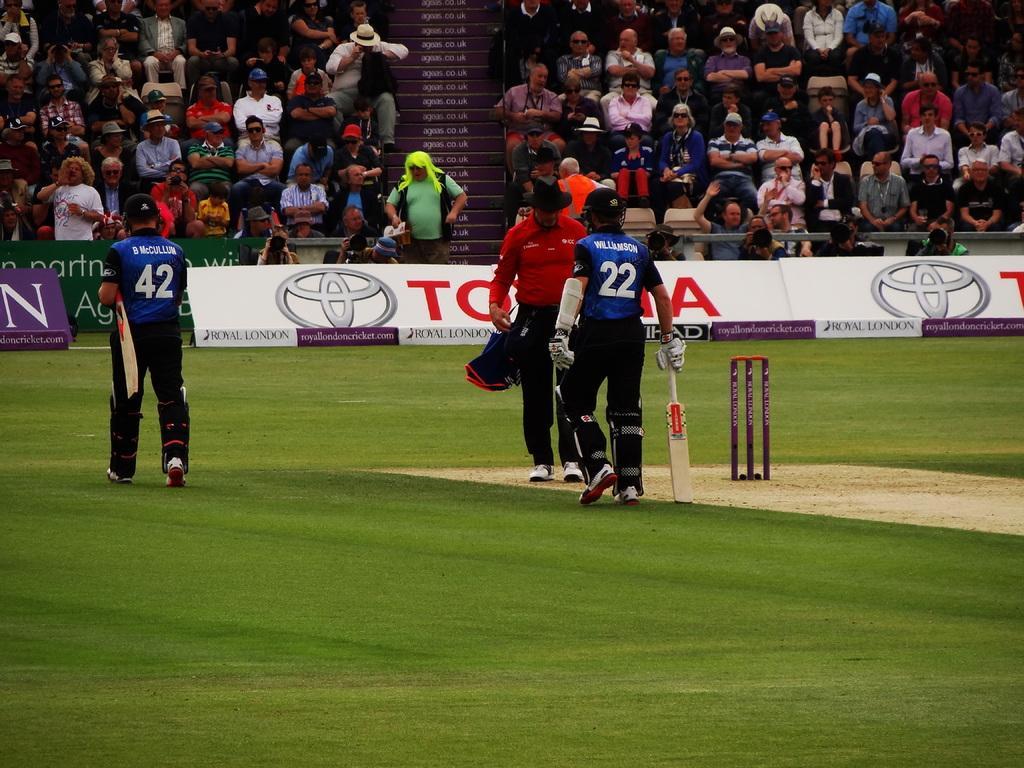Describe this image in one or two sentences. It is a cricket ground, here a man is walking by holding a bat, he wore a blue color t-shirt. Beside him, he is an empire, few people are sitting and observing this match from there. 